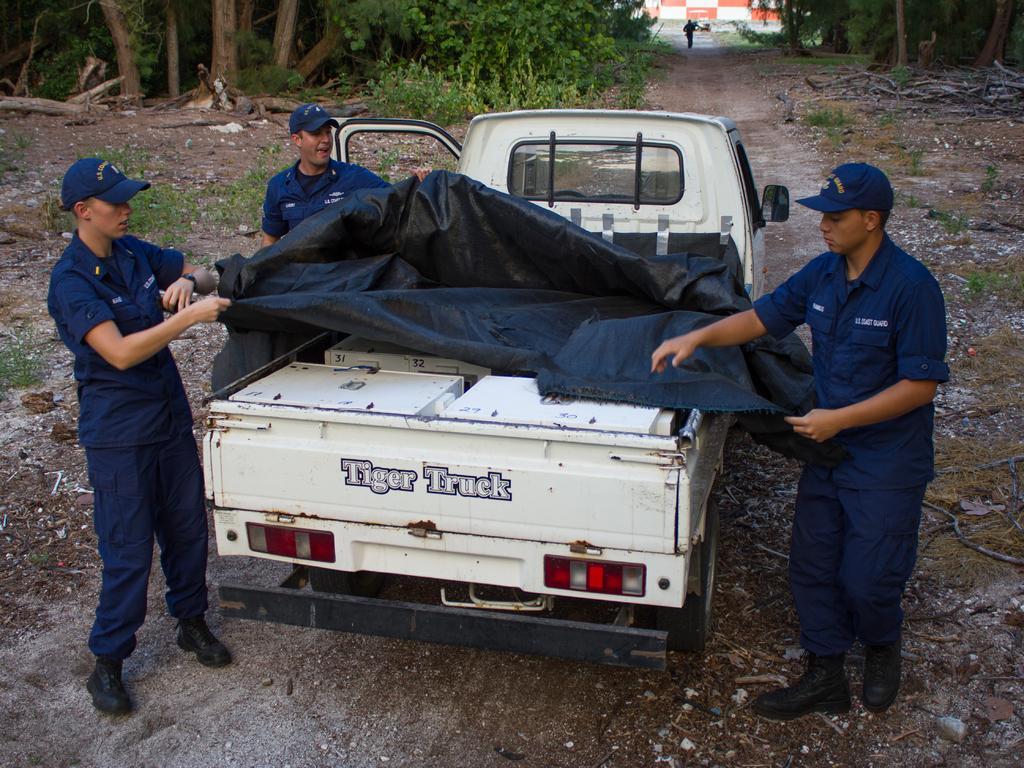In one or two sentences, can you explain what this image depicts? In this image there are three persons with uniform are standing and covering the load present in the truck. In the background there are trees, a wall and also a person walking on the land. 